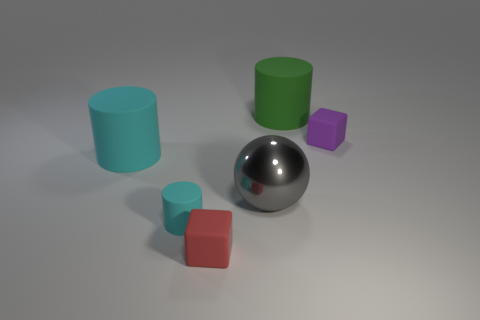Subtract all cyan matte cylinders. How many cylinders are left? 1 Add 2 large blue metallic balls. How many objects exist? 8 Subtract all cyan cylinders. How many cylinders are left? 1 Subtract 2 cubes. How many cubes are left? 0 Subtract all blue spheres. How many green cylinders are left? 1 Subtract all red objects. Subtract all tiny gray shiny cylinders. How many objects are left? 5 Add 2 green cylinders. How many green cylinders are left? 3 Add 1 gray metallic balls. How many gray metallic balls exist? 2 Subtract 0 brown blocks. How many objects are left? 6 Subtract all spheres. How many objects are left? 5 